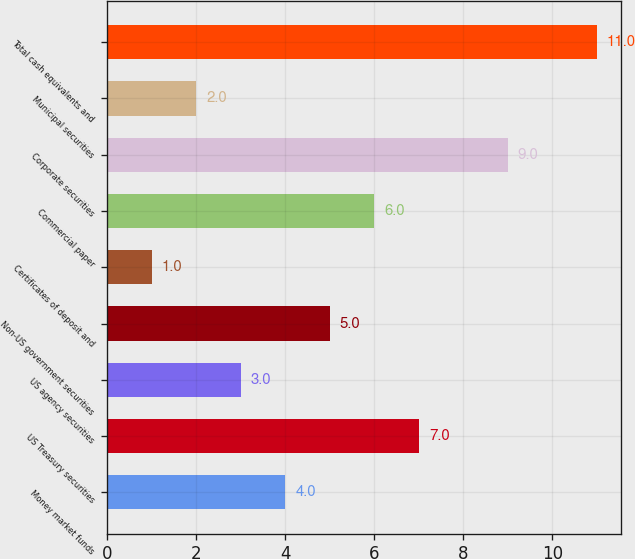<chart> <loc_0><loc_0><loc_500><loc_500><bar_chart><fcel>Money market funds<fcel>US Treasury securities<fcel>US agency securities<fcel>Non-US government securities<fcel>Certificates of deposit and<fcel>Commercial paper<fcel>Corporate securities<fcel>Municipal securities<fcel>Total cash equivalents and<nl><fcel>4<fcel>7<fcel>3<fcel>5<fcel>1<fcel>6<fcel>9<fcel>2<fcel>11<nl></chart> 